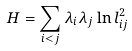<formula> <loc_0><loc_0><loc_500><loc_500>H = \sum _ { i < j } \lambda _ { i } \lambda _ { j } \ln l _ { i j } ^ { 2 }</formula> 